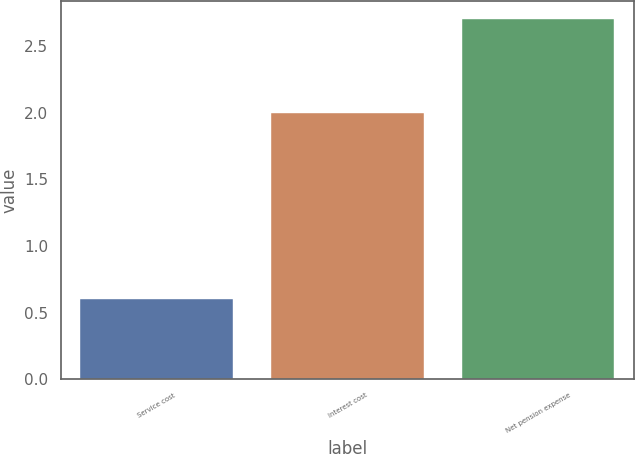<chart> <loc_0><loc_0><loc_500><loc_500><bar_chart><fcel>Service cost<fcel>Interest cost<fcel>Net pension expense<nl><fcel>0.6<fcel>2<fcel>2.7<nl></chart> 